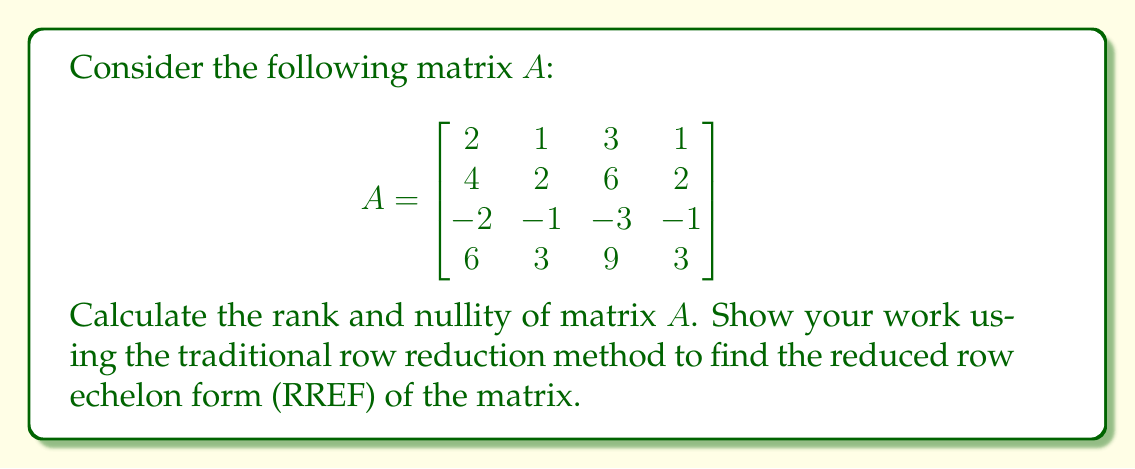Solve this math problem. Step 1: Convert matrix $A$ to reduced row echelon form (RREF).

$$\begin{bmatrix}
2 & 1 & 3 & 1 \\
4 & 2 & 6 & 2 \\
-2 & -1 & -3 & -1 \\
6 & 3 & 9 & 3
\end{bmatrix} \sim
\begin{bmatrix}
1 & \frac{1}{2} & \frac{3}{2} & \frac{1}{2} \\
0 & 0 & 0 & 0 \\
0 & 0 & 0 & 0 \\
0 & 0 & 0 & 0
\end{bmatrix}$$

Step 2: Determine the rank.
The rank of a matrix is equal to the number of non-zero rows in its RREF. In this case, there is only one non-zero row, so:

Rank$(A) = 1$

Step 3: Calculate the nullity using the Rank-Nullity Theorem.
The Rank-Nullity Theorem states that for a matrix $A$ with $n$ columns:

Rank$(A)$ + Nullity$(A) = n$

We know that $A$ has 4 columns and Rank$(A) = 1$, so:

$1 + \text{Nullity}(A) = 4$
$\text{Nullity}(A) = 4 - 1 = 3$

Therefore, the nullity of matrix $A$ is 3.
Answer: Rank$(A) = 1$, Nullity$(A) = 3$ 